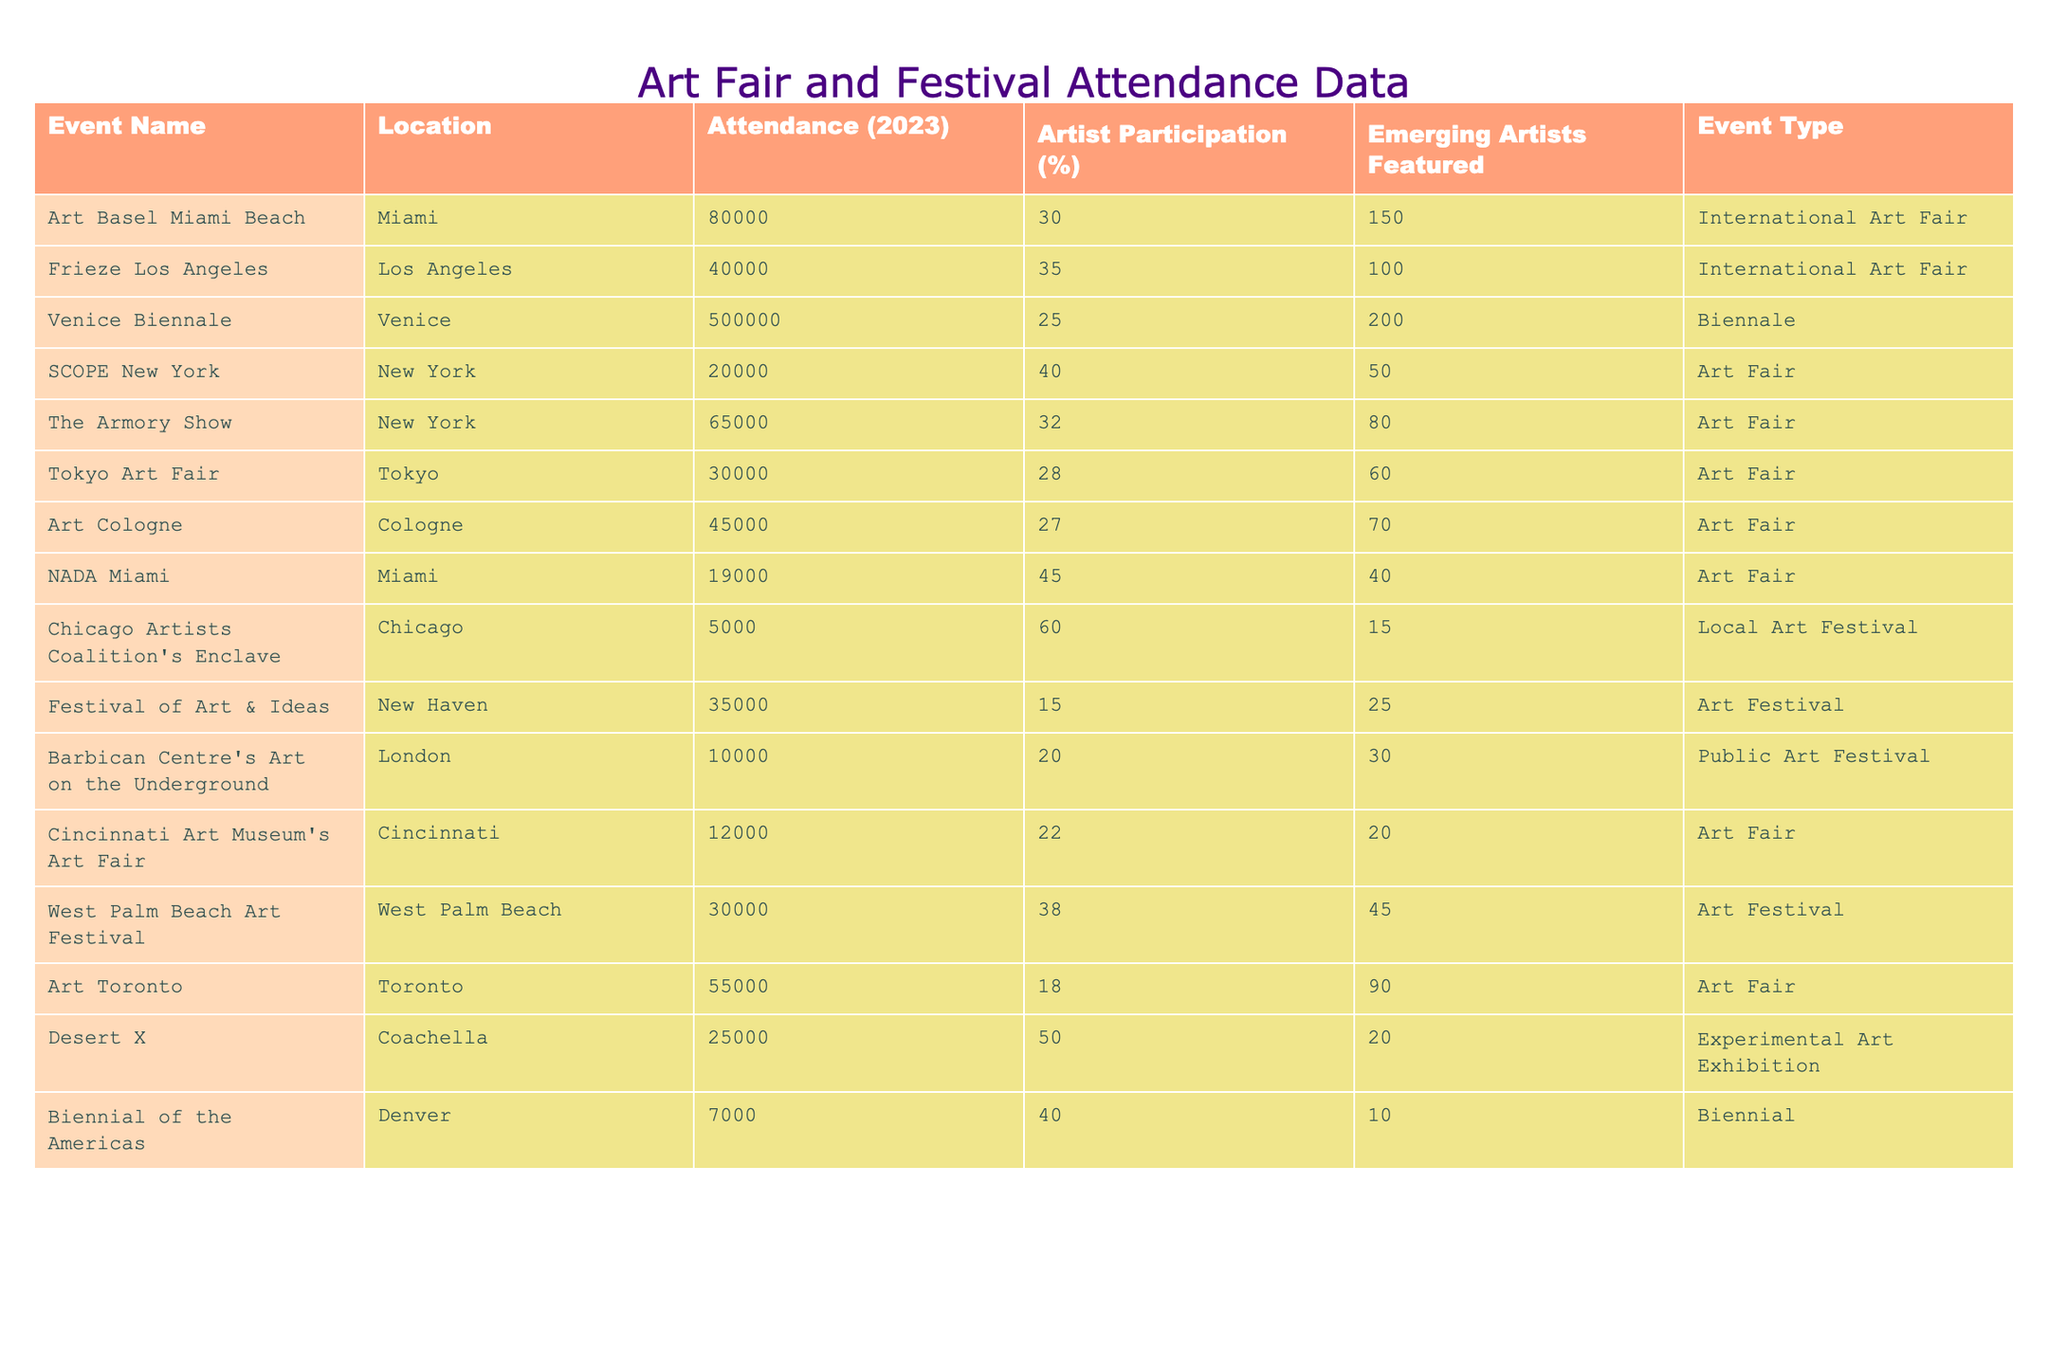What is the total attendance at all events listed? To find the total attendance, I will sum the attendance figures: 80000 + 40000 + 500000 + 20000 + 65000 + 30000 + 45000 + 19000 + 5000 + 35000 + 10000 + 12000 + 30000 + 55000 + 25000 + 7000 = 774,000.
Answer: 774000 Which event had the highest attendance? I will look through the attendance column to identify the highest figure, which is 500000 for the Venice Biennale.
Answer: Venice Biennale How many emerging artists were featured in the Frieze Los Angeles event? The number of emerging artists featured in Frieze Los Angeles is directly listed as 100 in the table.
Answer: 100 What percentage of the artists participating in the Chicago Artists Coalition's Enclave were emerging artists? The Chicago Artists Coalition's Enclave had 60% artist participation, indicating a significant portion of participating artists were emerging artists.
Answer: 60% How does the attendance of the Tokyo Art Fair compare to the Chicago Artists Coalition's Enclave? The attendance of the Tokyo Art Fair is 30000 while the Chicago Artists Coalition's Enclave has an attendance of 5000. The Tokyo Art Fair had 25000 more attendees.
Answer: 25000 Are there more emerging artists featured in the Art Fair or Art Festival events overall? I will count the emerging artists featured in Art Fair events (150 + 100 + 50 + 80 + 60 + 70 + 40 + 90= 640) and Art Festival events (25 + 30 + 20 + 45 + 10 = 130). 640 (Art Fair) is more than 130 (Art Festival).
Answer: Yes What is the average attendance at all events? The total attendance is 774000 and there are 16 events. The average attendance is 774000 / 16 = 48375.
Answer: 48375 Which event has the lowest attendance and what is that number? I look for the lowest number in the attendance column; the Chicago Artists Coalition's Enclave has the lowest attendance at 5000.
Answer: 5000 